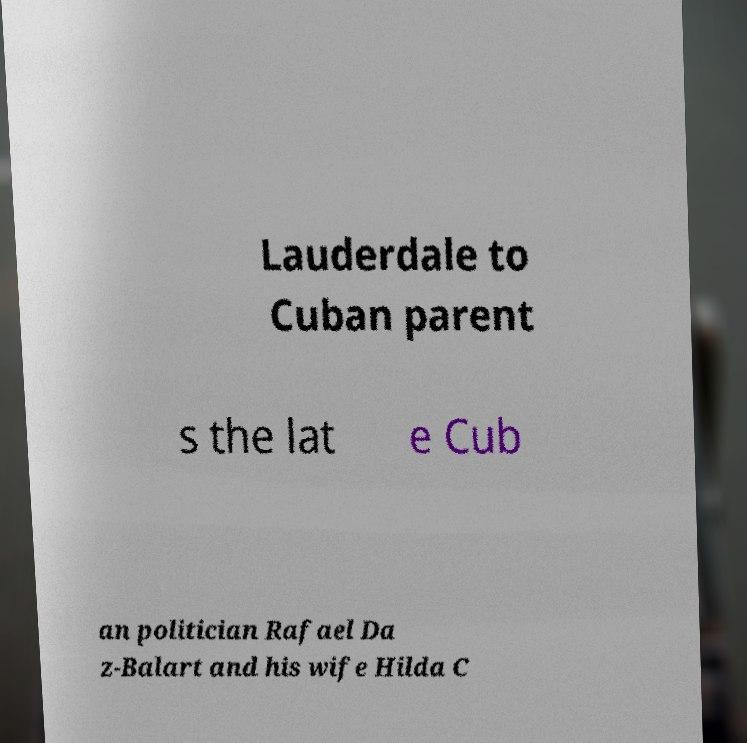I need the written content from this picture converted into text. Can you do that? Lauderdale to Cuban parent s the lat e Cub an politician Rafael Da z-Balart and his wife Hilda C 